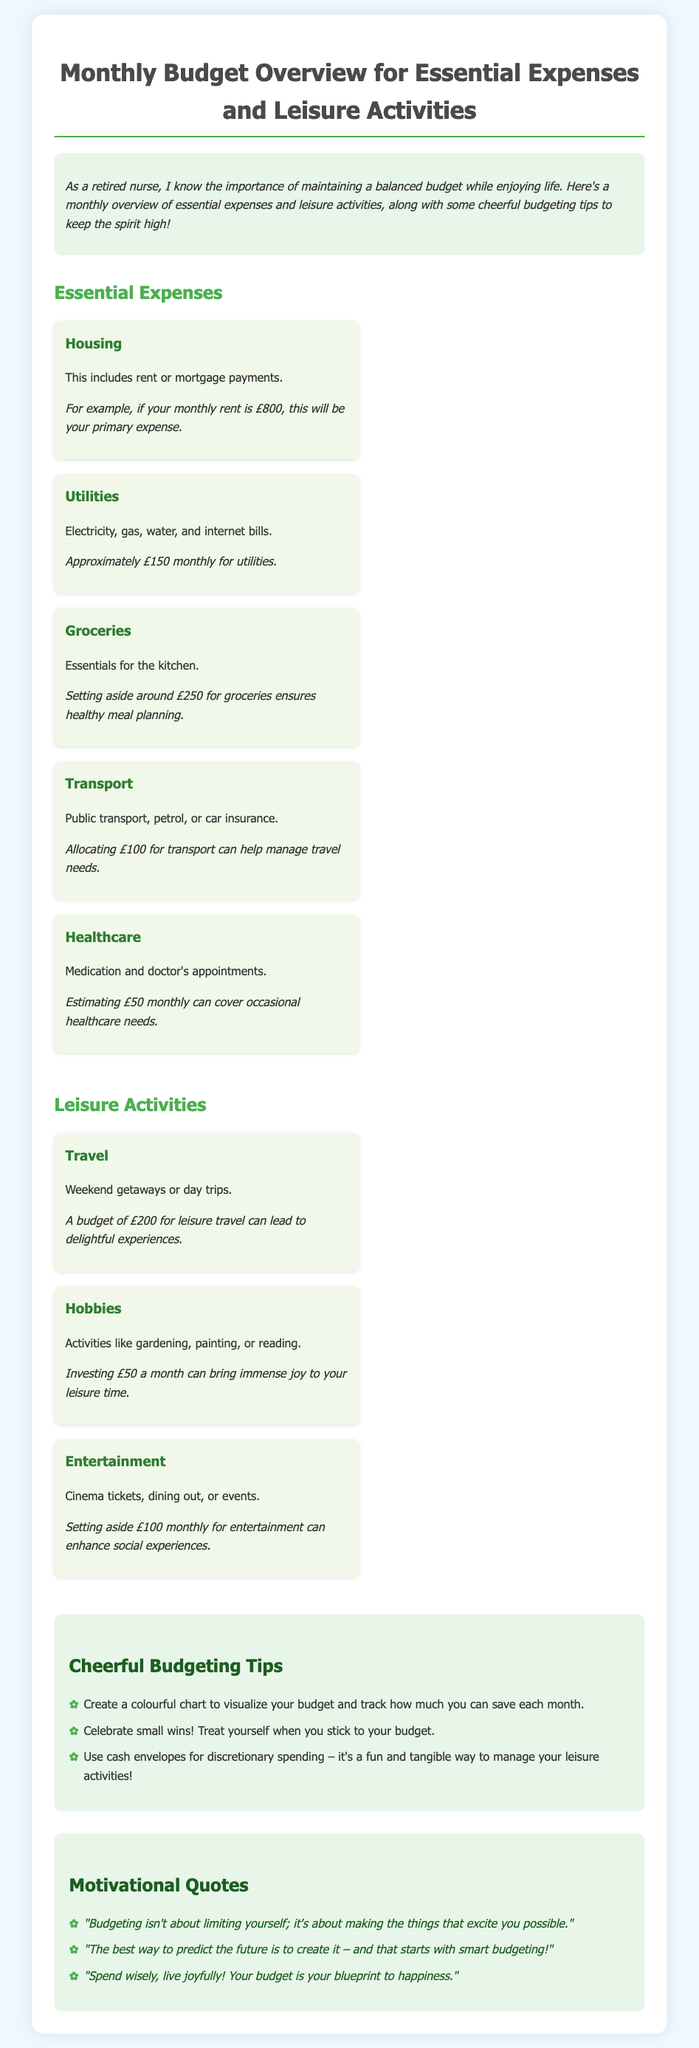what is the primary essential expense listed? The primary essential expense listed is Housing, which includes rent or mortgage payments.
Answer: Housing how much is allocated for groceries? The document states that setting aside around £250 for groceries ensures healthy meal planning.
Answer: £250 which leisure activity has a budget of £200? The leisure activity with a budget of £200 is Travel, which can lead to delightful experiences.
Answer: Travel how much is budgeted for utilities? The document estimates approximately £150 monthly for utilities.
Answer: £150 what is the total estimated monthly budget for essential expenses? The total estimated monthly budget for essential expenses can be calculated by adding Housing (£800), Utilities (£150), Groceries (£250), Transport (£100), and Healthcare (£50). This totals £1350.
Answer: £1350 how can one visualize their budget? According to the tips, one can create a colourful chart to visualize their budget.
Answer: A colourful chart what is the quote about predicting the future? The quote states, "The best way to predict the future is to create it – and that starts with smart budgeting!"
Answer: "The best way to predict the future is to create it – and that starts with smart budgeting!" how much is recommended for hobbies? The document suggests investing £50 a month for hobbies to bring immense joy to leisure time.
Answer: £50 what activity does the tips section suggest for managing leisure spending? The tips suggest using cash envelopes for discretionary spending.
Answer: Cash envelopes 